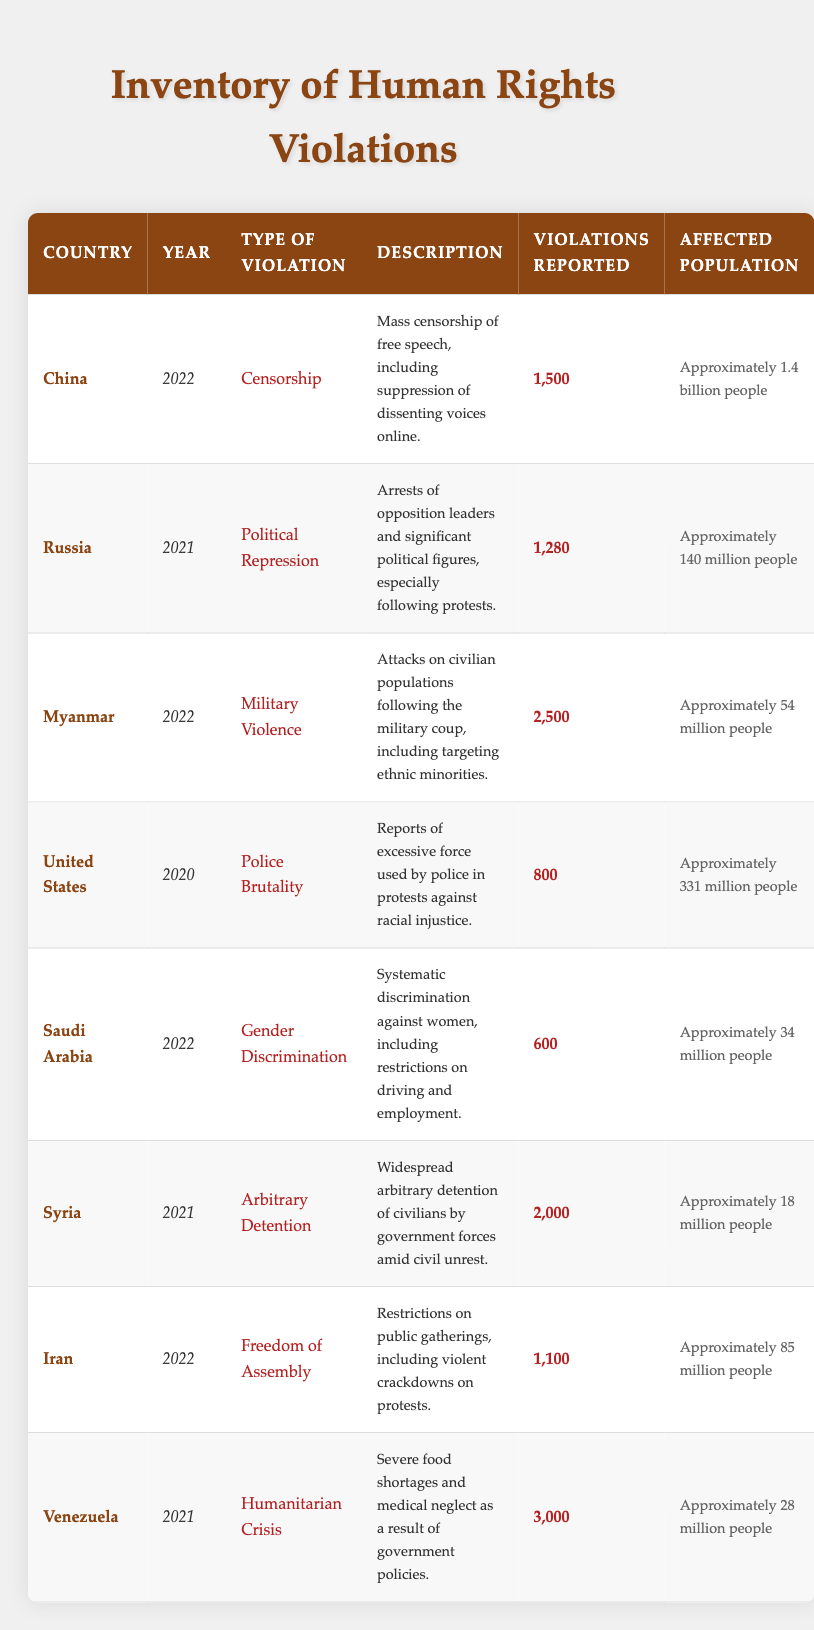What type of human rights violation was reported in Iran in 2022? The table lists the type of violation for each entry. For Iran in 2022, the violation type is "Freedom of Assembly."
Answer: Freedom of Assembly Which country reported the highest number of human rights violations in 2021? To find this, we compare the "Violations Reported" column for the years 2021. Russia reported 1,280, Syria reported 2,000, and Venezuela reported 3,000. The highest is Venezuela with 3,000.
Answer: Venezuela Is there any country reported for gender discrimination in 2022? Looking at the table, Saudi Arabia is the only country listed for that year with the violation type "Gender Discrimination."
Answer: Yes What is the total number of violations reported for Myanmar and Syria combined in 2022 and 2021? For Myanmar in 2022, there were 2,500 violations, and for Syria in 2021, there were 2,000 violations. Adding these gives 2,500 + 2,000 = 4,500 total violations.
Answer: 4,500 Did any country report less than 1,000 violations in 2020? Looking at the table, the only violation-related entry for 2020 is the United States, which reported 800 violations. Therefore, the answer is yes.
Answer: Yes Which country witnessed military violence in 2022, and how many violations were reported? By checking the table, we see that Myanmar was associated with "Military Violence" in 2022, with 2,500 violations reported.
Answer: Myanmar, 2,500 How many people were affected by the violations reported in Saudi Arabia in 2022? The affected population for Saudi Arabia in 2022 is stated in the table as approximately 34 million people.
Answer: Approximately 34 million people What is the difference in the number of violations reported between Venezuela in 2021 and Myanmar in 2022? Venezuela had 3,000 violations in 2021, while Myanmar had 2,500 violations in 2022. The difference is calculated as 3,000 - 2,500 = 500 violations.
Answer: 500 Which country had more than 2,000 violations reported and in what type of violation? The table shows that Myanmar had 2,500 violations (Military Violence) and Venezuela had 3,000 violations (Humanitarian Crisis). Both exceed 2,000.
Answer: Myanmar (Military Violence), Venezuela (Humanitarian Crisis) 